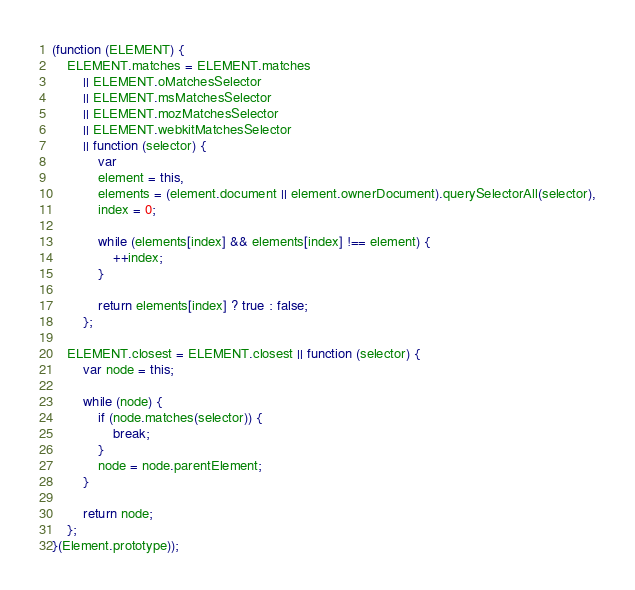<code> <loc_0><loc_0><loc_500><loc_500><_JavaScript_>(function (ELEMENT) {
	ELEMENT.matches = ELEMENT.matches
		|| ELEMENT.oMatchesSelector
		|| ELEMENT.msMatchesSelector
		|| ELEMENT.mozMatchesSelector
		|| ELEMENT.webkitMatchesSelector
		|| function (selector) {
			var
			element = this,
			elements = (element.document || element.ownerDocument).querySelectorAll(selector),
			index = 0;

			while (elements[index] && elements[index] !== element) {
				++index;
			}

			return elements[index] ? true : false;
		};

	ELEMENT.closest = ELEMENT.closest || function (selector) {
		var node = this;

		while (node) {
			if (node.matches(selector)) {
				break;
			}
			node = node.parentElement;
		}

		return node;
	};
}(Element.prototype));
</code> 